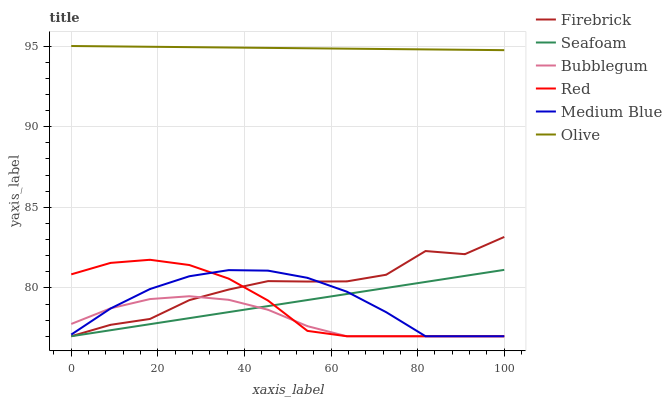Does Bubblegum have the minimum area under the curve?
Answer yes or no. Yes. Does Olive have the maximum area under the curve?
Answer yes or no. Yes. Does Medium Blue have the minimum area under the curve?
Answer yes or no. No. Does Medium Blue have the maximum area under the curve?
Answer yes or no. No. Is Olive the smoothest?
Answer yes or no. Yes. Is Firebrick the roughest?
Answer yes or no. Yes. Is Medium Blue the smoothest?
Answer yes or no. No. Is Medium Blue the roughest?
Answer yes or no. No. Does Firebrick have the lowest value?
Answer yes or no. Yes. Does Olive have the lowest value?
Answer yes or no. No. Does Olive have the highest value?
Answer yes or no. Yes. Does Medium Blue have the highest value?
Answer yes or no. No. Is Bubblegum less than Olive?
Answer yes or no. Yes. Is Olive greater than Red?
Answer yes or no. Yes. Does Bubblegum intersect Seafoam?
Answer yes or no. Yes. Is Bubblegum less than Seafoam?
Answer yes or no. No. Is Bubblegum greater than Seafoam?
Answer yes or no. No. Does Bubblegum intersect Olive?
Answer yes or no. No. 